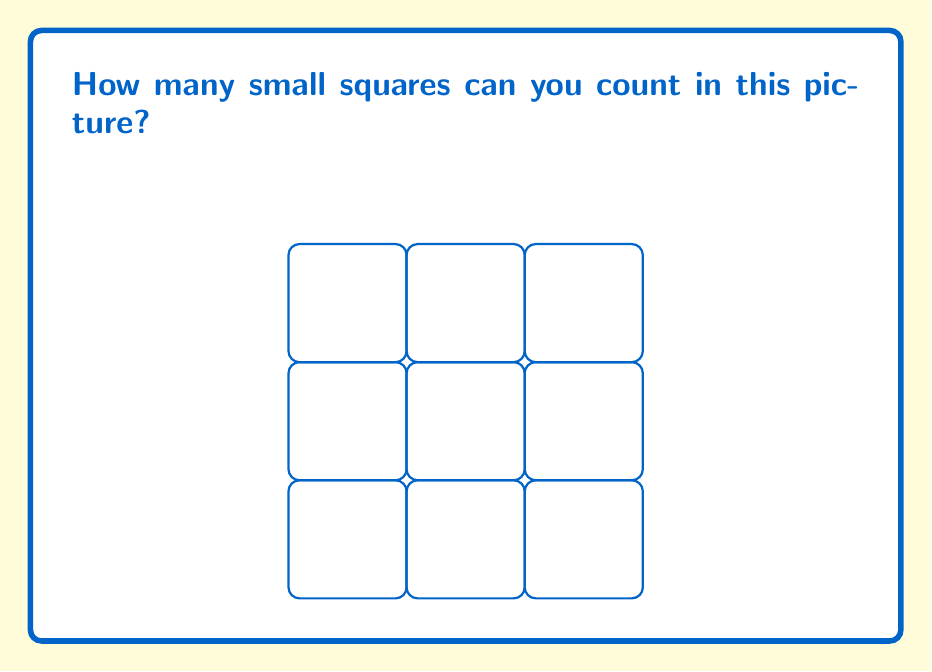What is the answer to this math problem? Let's count the squares together:

1. First, we can count the smallest squares. There are 9 of these. We can count them row by row:
   - In the top row: 1, 2, 3
   - In the middle row: 4, 5, 6
   - In the bottom row: 7, 8, 9

2. Now, let's look for bigger squares. Can you see any squares made up of 4 small squares? There are 4 of these:
   - Top left
   - Top right
   - Bottom left
   - Bottom right

3. Finally, there's one big square that covers the whole picture. It's made up of all 9 small squares.

So, to get the total number of squares, we add:
$$ 9 + 4 + 1 = 14 $$

That means there are 14 squares in total!
Answer: 14 squares 